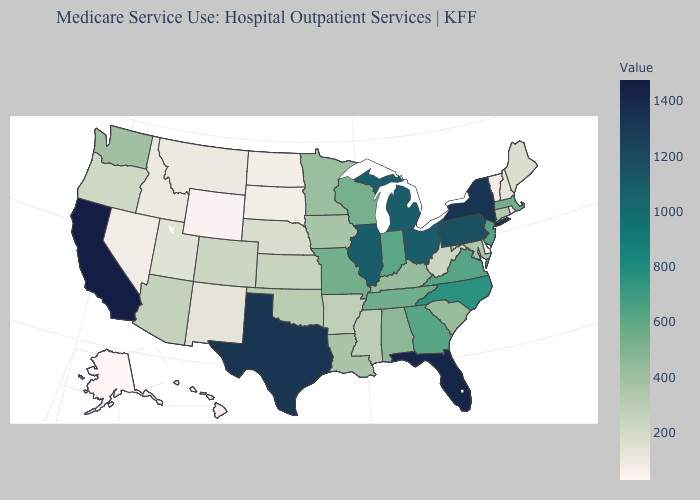Among the states that border South Carolina , which have the lowest value?
Write a very short answer. Georgia. Does Nebraska have the lowest value in the MidWest?
Give a very brief answer. No. Is the legend a continuous bar?
Keep it brief. Yes. Among the states that border Georgia , does Alabama have the lowest value?
Give a very brief answer. No. 